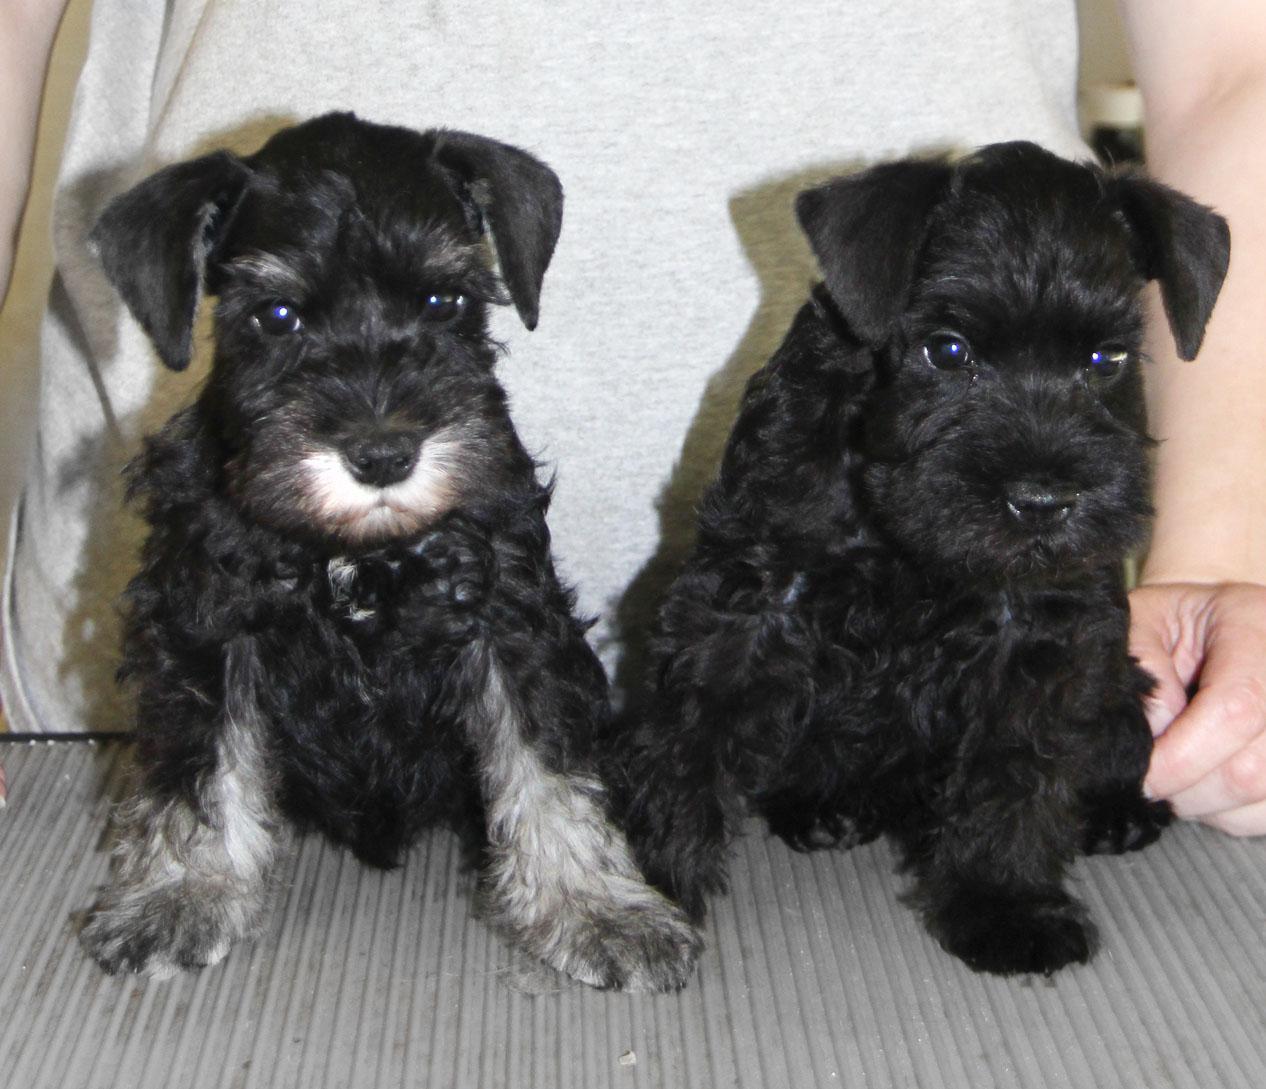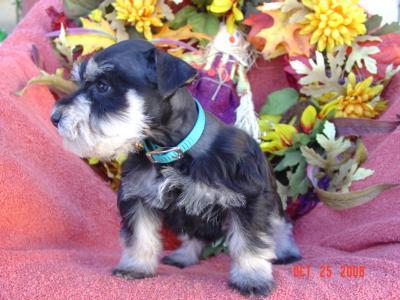The first image is the image on the left, the second image is the image on the right. Examine the images to the left and right. Is the description "An image shows a mother dog in a wood-sided crate with several puppies." accurate? Answer yes or no. No. The first image is the image on the left, the second image is the image on the right. Given the left and right images, does the statement "A wooden box with pink blankets is full of puppies" hold true? Answer yes or no. No. 